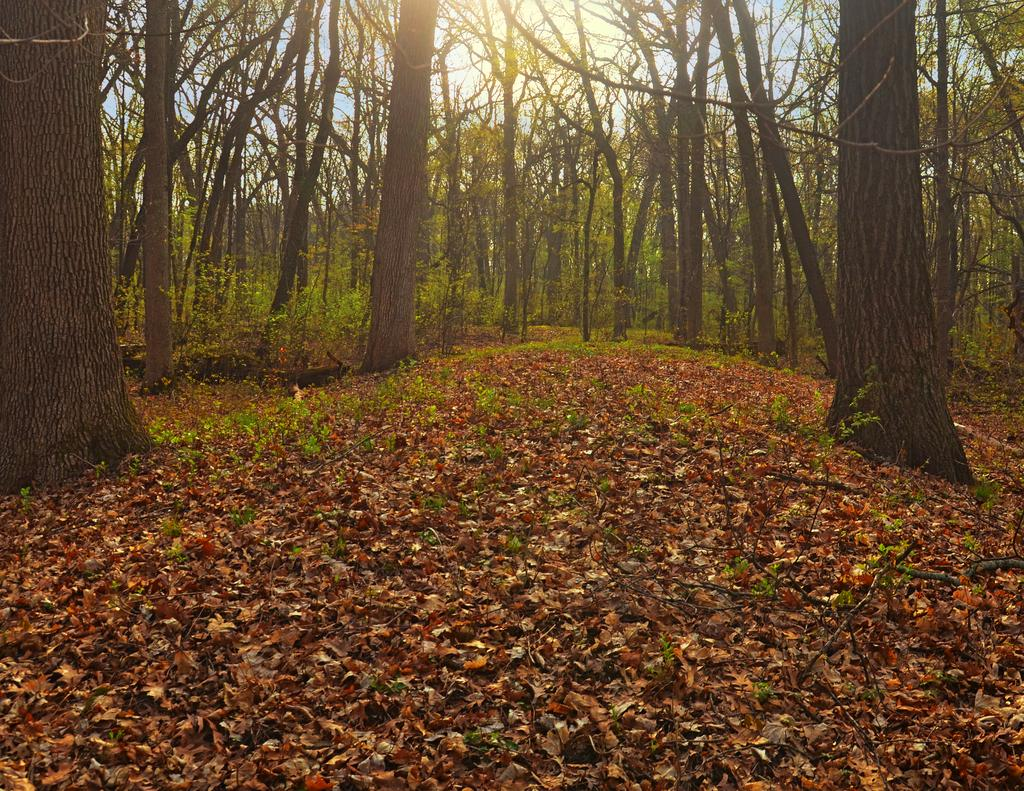What is present on the ground in the image? There are dry leaves on the ground in the image. What can be seen in the background of the image? There are trees visible in the background of the image. What type of vegetation is present in the image? The image features trees and dry leaves on the ground. How many frogs can be seen hopping around in the image? There are no frogs present in the image. Is there a person visible in the image? There is no person visible in the image. 